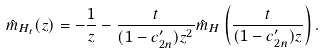Convert formula to latex. <formula><loc_0><loc_0><loc_500><loc_500>\hat { m } _ { H _ { t } } ( z ) = - \frac { 1 } { z } - \frac { t } { ( 1 - c _ { 2 n } ^ { \prime } ) z ^ { 2 } } \hat { m } _ { H } \left ( \frac { t } { ( 1 - c _ { 2 n } ^ { \prime } ) z } \right ) .</formula> 